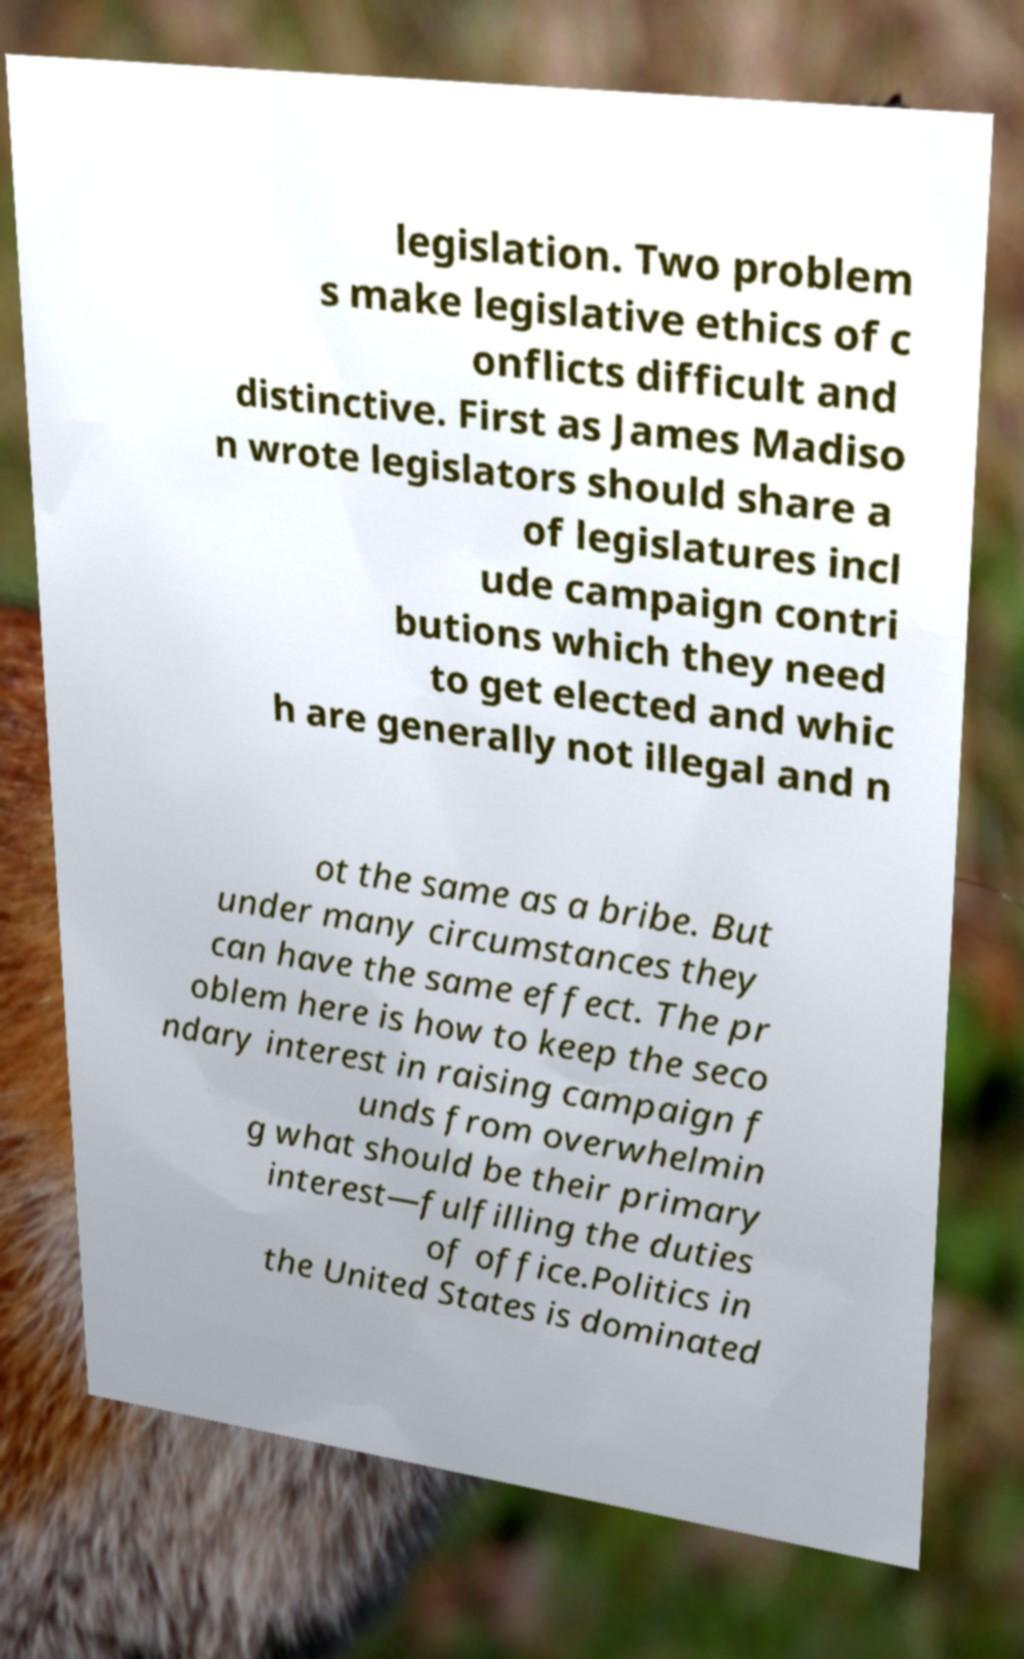Could you extract and type out the text from this image? legislation. Two problem s make legislative ethics of c onflicts difficult and distinctive. First as James Madiso n wrote legislators should share a of legislatures incl ude campaign contri butions which they need to get elected and whic h are generally not illegal and n ot the same as a bribe. But under many circumstances they can have the same effect. The pr oblem here is how to keep the seco ndary interest in raising campaign f unds from overwhelmin g what should be their primary interest—fulfilling the duties of office.Politics in the United States is dominated 